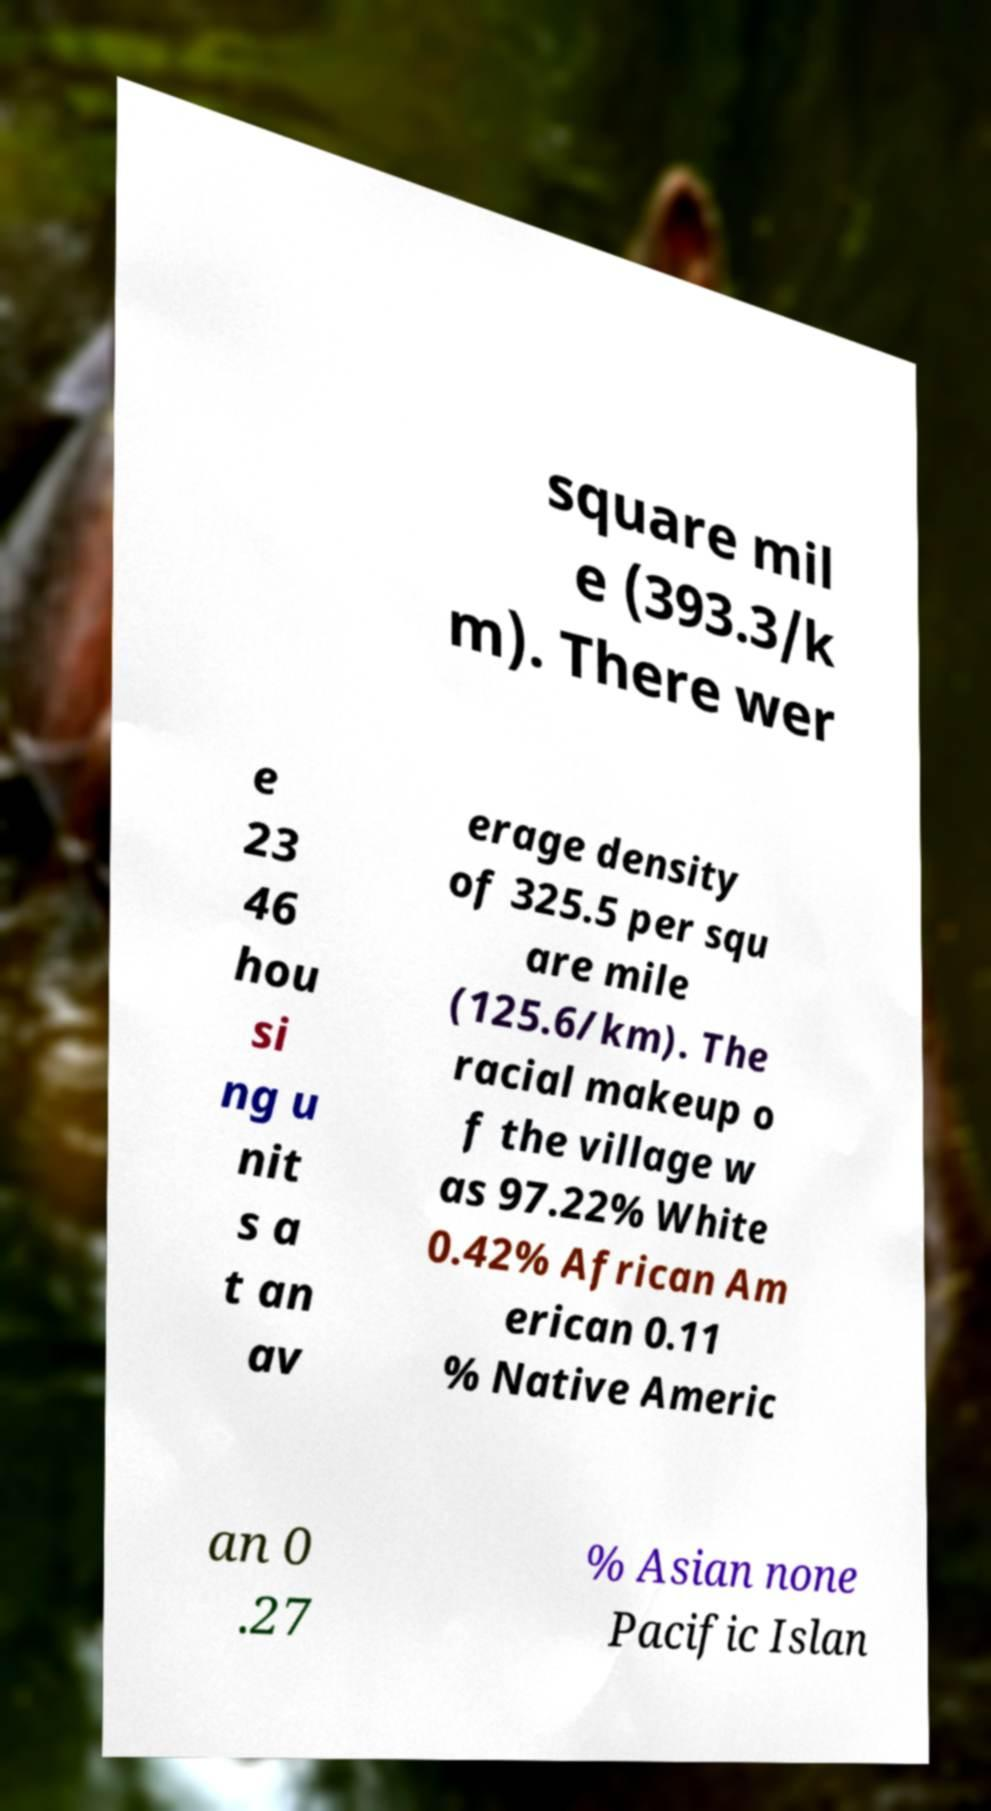Can you accurately transcribe the text from the provided image for me? square mil e (393.3/k m). There wer e 23 46 hou si ng u nit s a t an av erage density of 325.5 per squ are mile (125.6/km). The racial makeup o f the village w as 97.22% White 0.42% African Am erican 0.11 % Native Americ an 0 .27 % Asian none Pacific Islan 